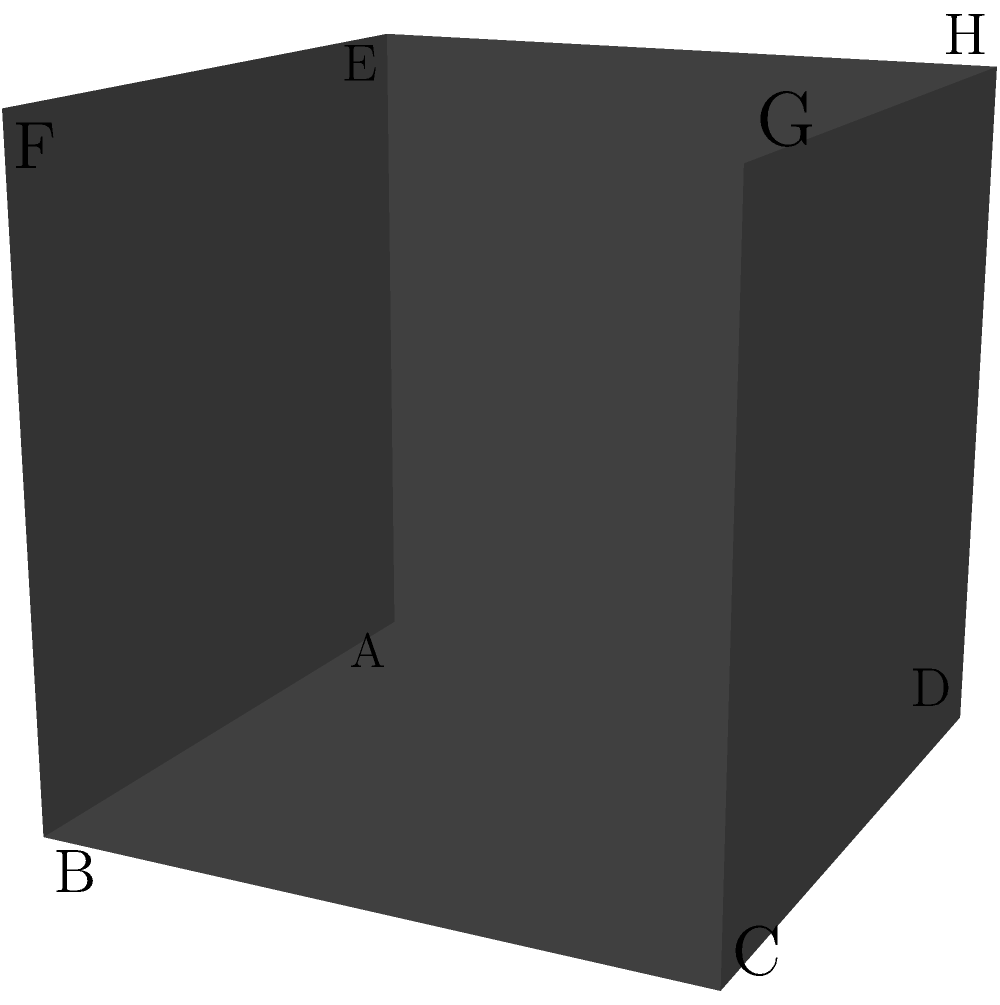In the complex polyhedron shown, some faces appear to fade in and out of visibility. The cube has side length 2 units. If the fading faces (ABFE and CDHG) are considered to have only half their usual contribution to the volume, calculate the total effective volume of this altered polyhedron. To solve this problem, let's break it down into steps:

1) First, calculate the volume of the full cube:
   $$V_{cube} = s^3 = 2^3 = 8$$ cubic units

2) The fading faces (ABFE and CDHG) are opposite each other and divide the cube into three sections.

3) Each of these sections has a volume of:
   $$V_{section} = s^2 \times \frac{s}{3} = 2^2 \times \frac{2}{3} = \frac{8}{3}$$ cubic units

4) The middle section remains unchanged, but the two outer sections (containing the fading faces) are affected.

5) For each outer section, we consider only half of its volume due to the fading face:
   $$V_{outer} = \frac{1}{2} \times \frac{8}{3} = \frac{4}{3}$$ cubic units

6) The total effective volume is the sum of the middle section and the two halved outer sections:
   $$V_{total} = \frac{8}{3} + \frac{4}{3} + \frac{4}{3} = \frac{16}{3}$$ cubic units

Therefore, the total effective volume of the altered polyhedron is $\frac{16}{3}$ cubic units.
Answer: $\frac{16}{3}$ cubic units 